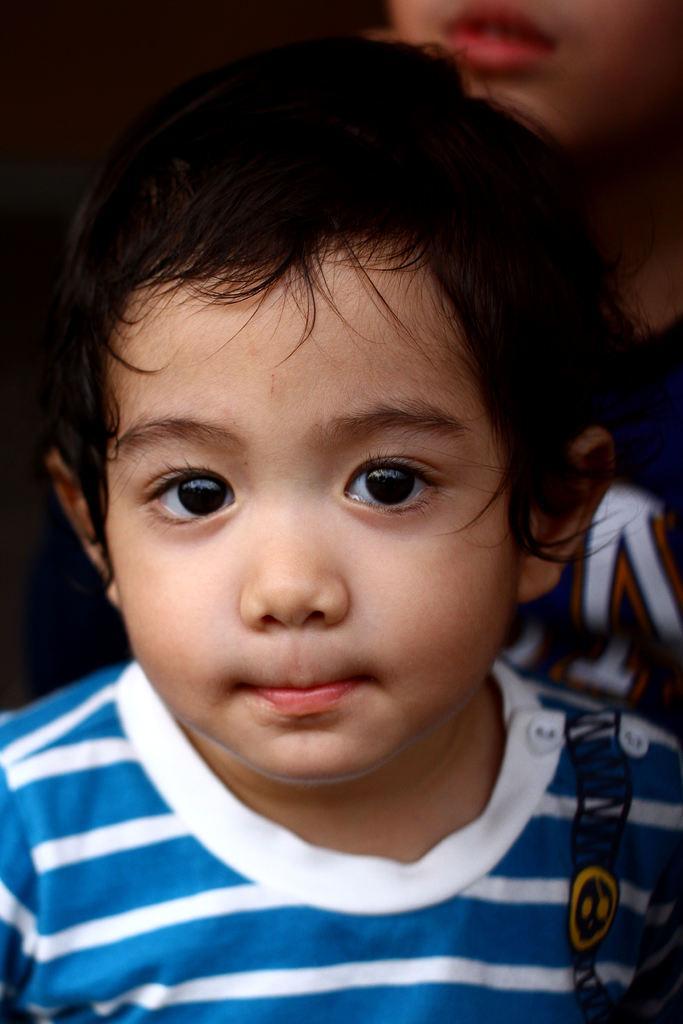Could you give a brief overview of what you see in this image? In this picture there is a boy with white and blue t-shirt. At the back there is a person. 